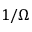<formula> <loc_0><loc_0><loc_500><loc_500>1 / \Omega</formula> 